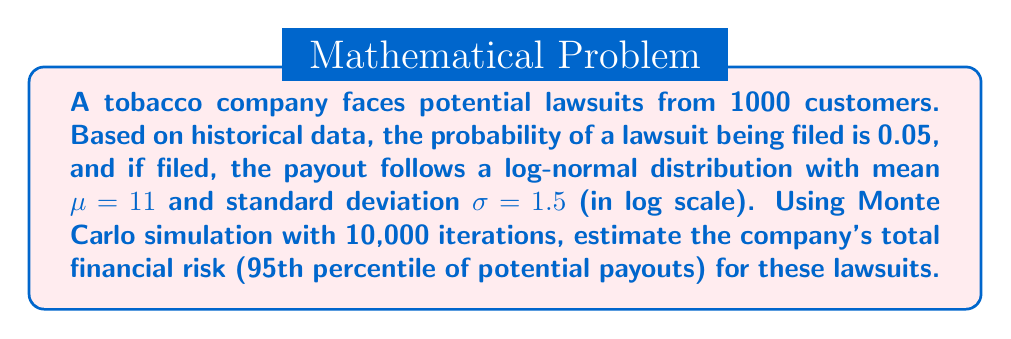Show me your answer to this math problem. 1) Set up the Monte Carlo simulation:
   - Number of iterations: 10,000
   - Number of potential lawsuits: 1000

2) For each iteration:
   a) Generate 1000 random numbers between 0 and 1 to determine which customers file lawsuits.
   b) Count the number of lawsuits (where random number < 0.05).
   c) For each lawsuit, generate a payout from the log-normal distribution:
      $X = e^{\mu + \sigma Z}$, where $Z$ is a standard normal random variable.
   d) Sum the payouts for this iteration.

3) After 10,000 iterations, we have a distribution of total payouts.

4) Calculate the 95th percentile of this distribution to estimate the financial risk.

Python code for the simulation:

```python
import numpy as np

np.random.seed(42)  # for reproducibility

iterations = 10000
customers = 1000
lawsuit_prob = 0.05
mu, sigma = 11, 1.5

results = []

for _ in range(iterations):
    lawsuits = np.random.random(customers) < lawsuit_prob
    num_lawsuits = np.sum(lawsuits)
    payouts = np.exp(np.random.normal(mu, sigma, num_lawsuits))
    total_payout = np.sum(payouts)
    results.append(total_payout)

risk_estimate = np.percentile(results, 95)
```

5) The 95th percentile of the simulation results represents the estimated financial risk.
Answer: $161,500,000 